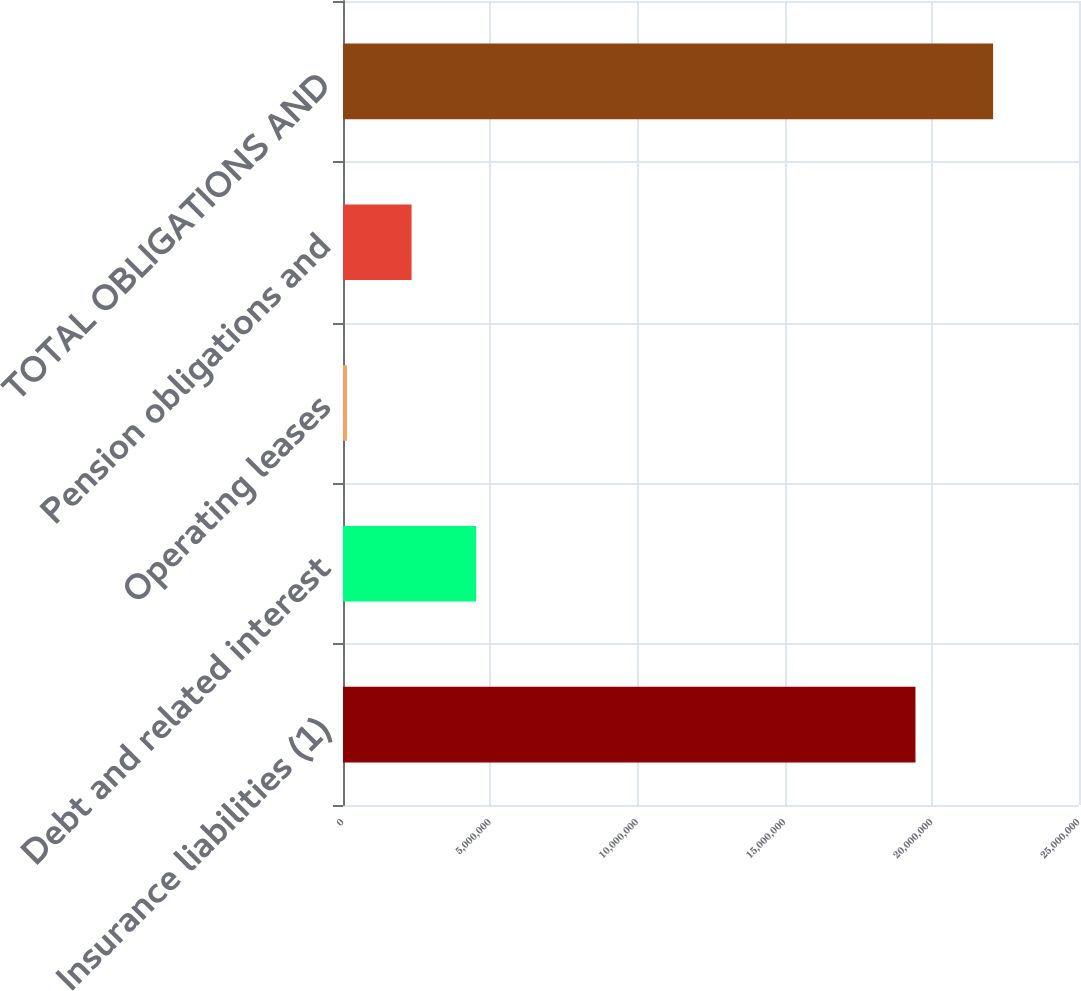Convert chart to OTSL. <chart><loc_0><loc_0><loc_500><loc_500><bar_chart><fcel>Insurance liabilities (1)<fcel>Debt and related interest<fcel>Operating leases<fcel>Pension obligations and<fcel>TOTAL OBLIGATIONS AND<nl><fcel>1.94452e+07<fcel>4.52337e+06<fcel>133572<fcel>2.32847e+06<fcel>2.20826e+07<nl></chart> 